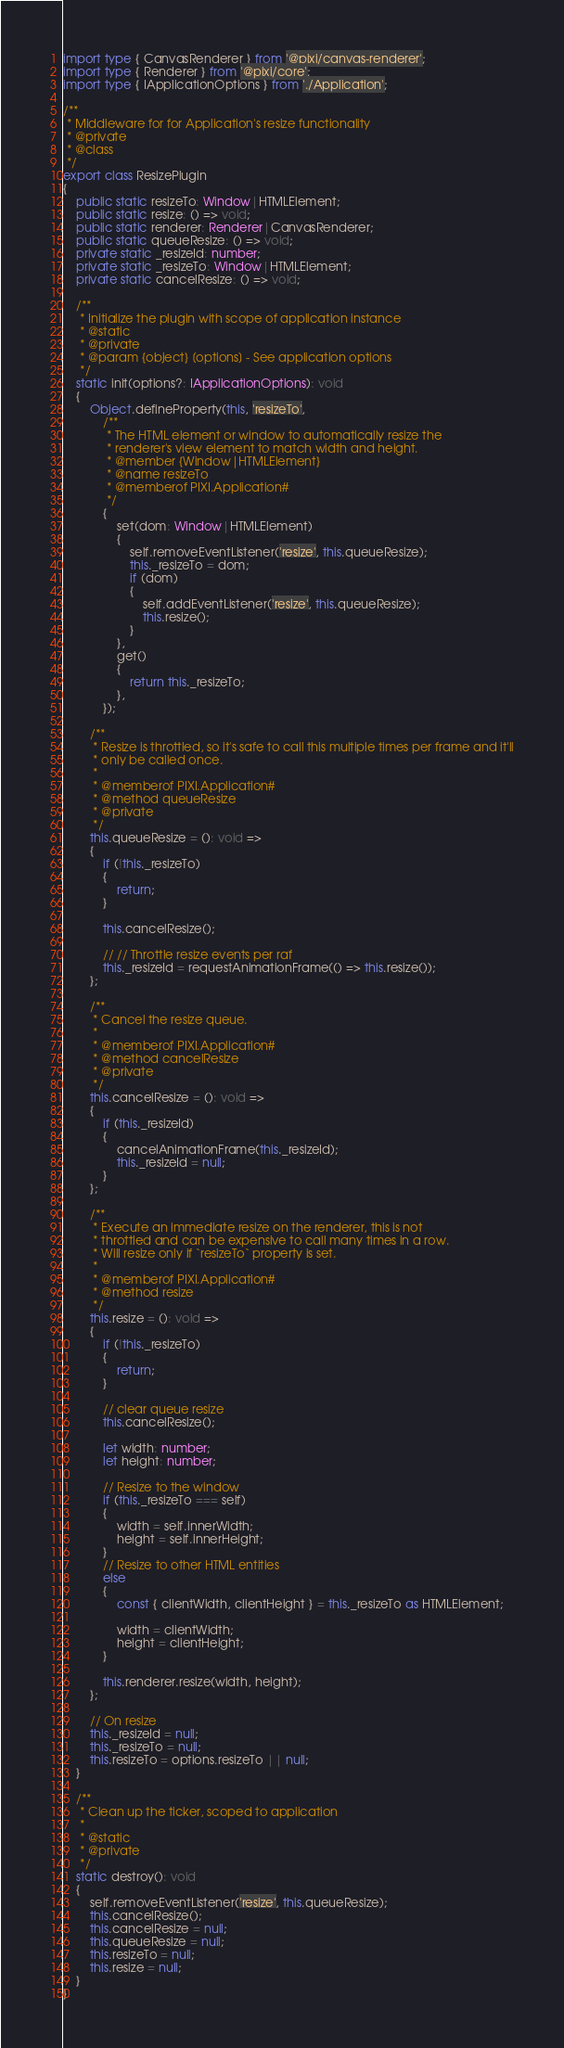<code> <loc_0><loc_0><loc_500><loc_500><_TypeScript_>import type { CanvasRenderer } from '@pixi/canvas-renderer';
import type { Renderer } from '@pixi/core';
import type { IApplicationOptions } from './Application';

/**
 * Middleware for for Application's resize functionality
 * @private
 * @class
 */
export class ResizePlugin
{
    public static resizeTo: Window|HTMLElement;
    public static resize: () => void;
    public static renderer: Renderer|CanvasRenderer;
    public static queueResize: () => void;
    private static _resizeId: number;
    private static _resizeTo: Window|HTMLElement;
    private static cancelResize: () => void;

    /**
     * Initialize the plugin with scope of application instance
     * @static
     * @private
     * @param {object} [options] - See application options
     */
    static init(options?: IApplicationOptions): void
    {
        Object.defineProperty(this, 'resizeTo',
            /**
             * The HTML element or window to automatically resize the
             * renderer's view element to match width and height.
             * @member {Window|HTMLElement}
             * @name resizeTo
             * @memberof PIXI.Application#
             */
            {
                set(dom: Window|HTMLElement)
                {
                    self.removeEventListener('resize', this.queueResize);
                    this._resizeTo = dom;
                    if (dom)
                    {
                        self.addEventListener('resize', this.queueResize);
                        this.resize();
                    }
                },
                get()
                {
                    return this._resizeTo;
                },
            });

        /**
         * Resize is throttled, so it's safe to call this multiple times per frame and it'll
         * only be called once.
         *
         * @memberof PIXI.Application#
         * @method queueResize
         * @private
         */
        this.queueResize = (): void =>
        {
            if (!this._resizeTo)
            {
                return;
            }

            this.cancelResize();

            // // Throttle resize events per raf
            this._resizeId = requestAnimationFrame(() => this.resize());
        };

        /**
         * Cancel the resize queue.
         *
         * @memberof PIXI.Application#
         * @method cancelResize
         * @private
         */
        this.cancelResize = (): void =>
        {
            if (this._resizeId)
            {
                cancelAnimationFrame(this._resizeId);
                this._resizeId = null;
            }
        };

        /**
         * Execute an immediate resize on the renderer, this is not
         * throttled and can be expensive to call many times in a row.
         * Will resize only if `resizeTo` property is set.
         *
         * @memberof PIXI.Application#
         * @method resize
         */
        this.resize = (): void =>
        {
            if (!this._resizeTo)
            {
                return;
            }

            // clear queue resize
            this.cancelResize();

            let width: number;
            let height: number;

            // Resize to the window
            if (this._resizeTo === self)
            {
                width = self.innerWidth;
                height = self.innerHeight;
            }
            // Resize to other HTML entities
            else
            {
                const { clientWidth, clientHeight } = this._resizeTo as HTMLElement;

                width = clientWidth;
                height = clientHeight;
            }

            this.renderer.resize(width, height);
        };

        // On resize
        this._resizeId = null;
        this._resizeTo = null;
        this.resizeTo = options.resizeTo || null;
    }

    /**
     * Clean up the ticker, scoped to application
     *
     * @static
     * @private
     */
    static destroy(): void
    {
        self.removeEventListener('resize', this.queueResize);
        this.cancelResize();
        this.cancelResize = null;
        this.queueResize = null;
        this.resizeTo = null;
        this.resize = null;
    }
}
</code> 